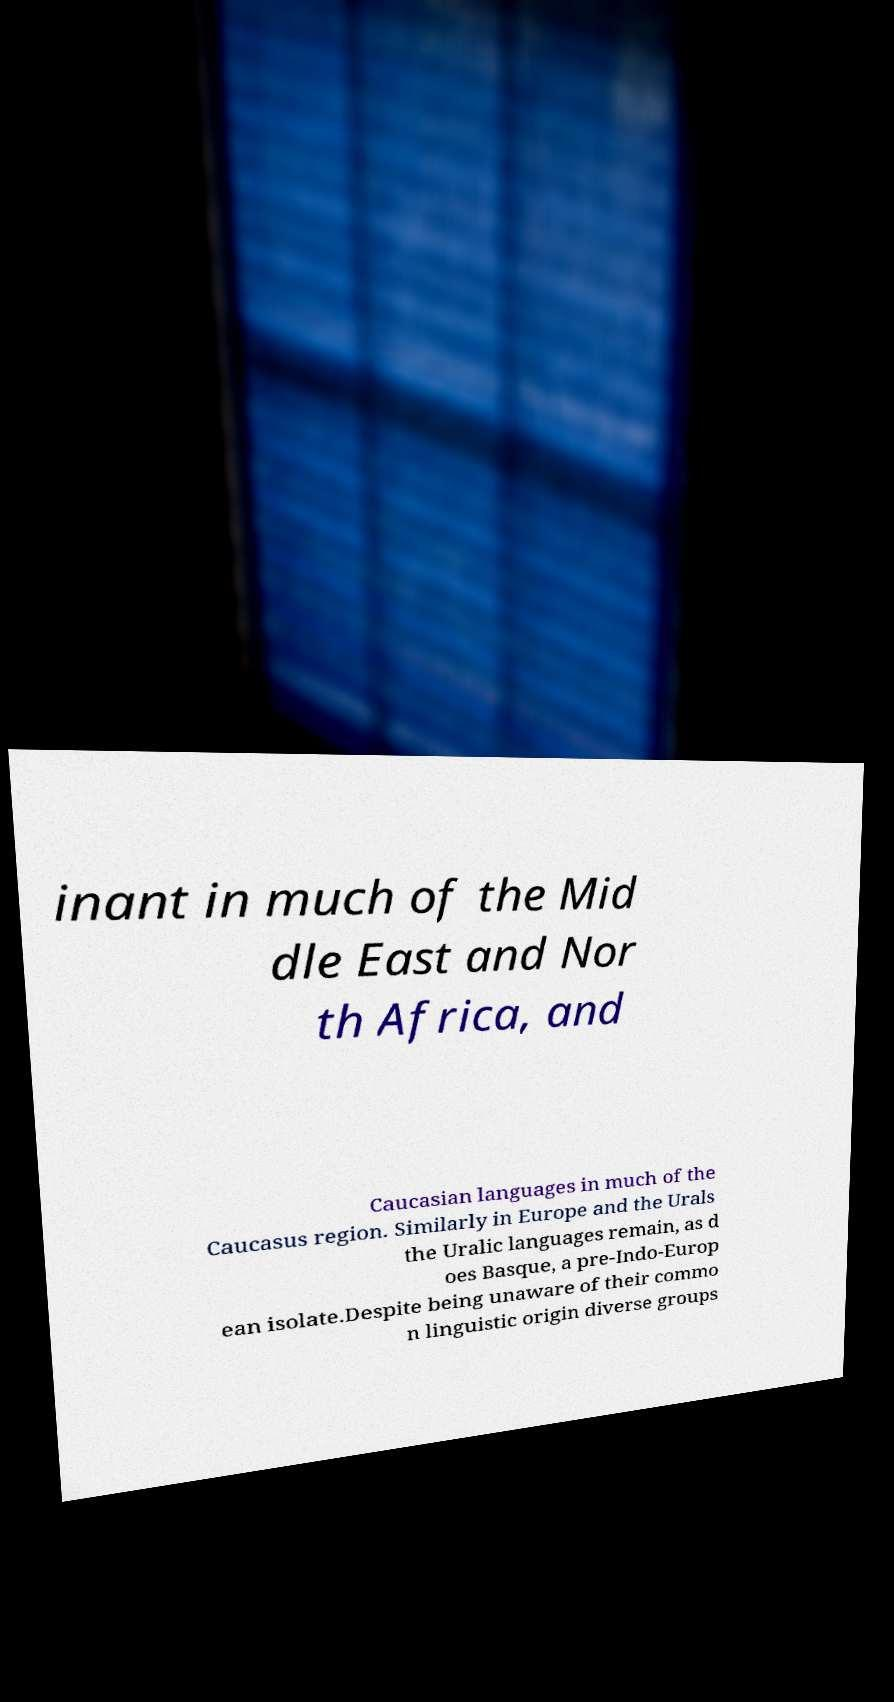What messages or text are displayed in this image? I need them in a readable, typed format. inant in much of the Mid dle East and Nor th Africa, and Caucasian languages in much of the Caucasus region. Similarly in Europe and the Urals the Uralic languages remain, as d oes Basque, a pre-Indo-Europ ean isolate.Despite being unaware of their commo n linguistic origin diverse groups 